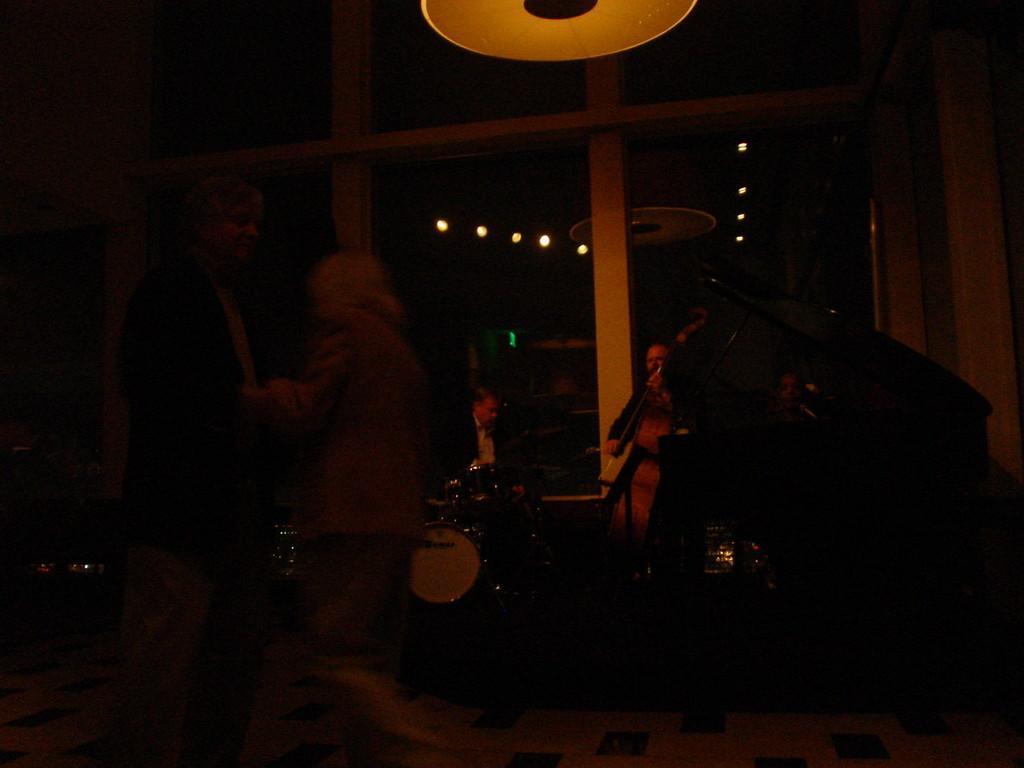Please provide a concise description of this image. In this image I can see few people and few musical instruments. I can see few lights and the image is dark. 